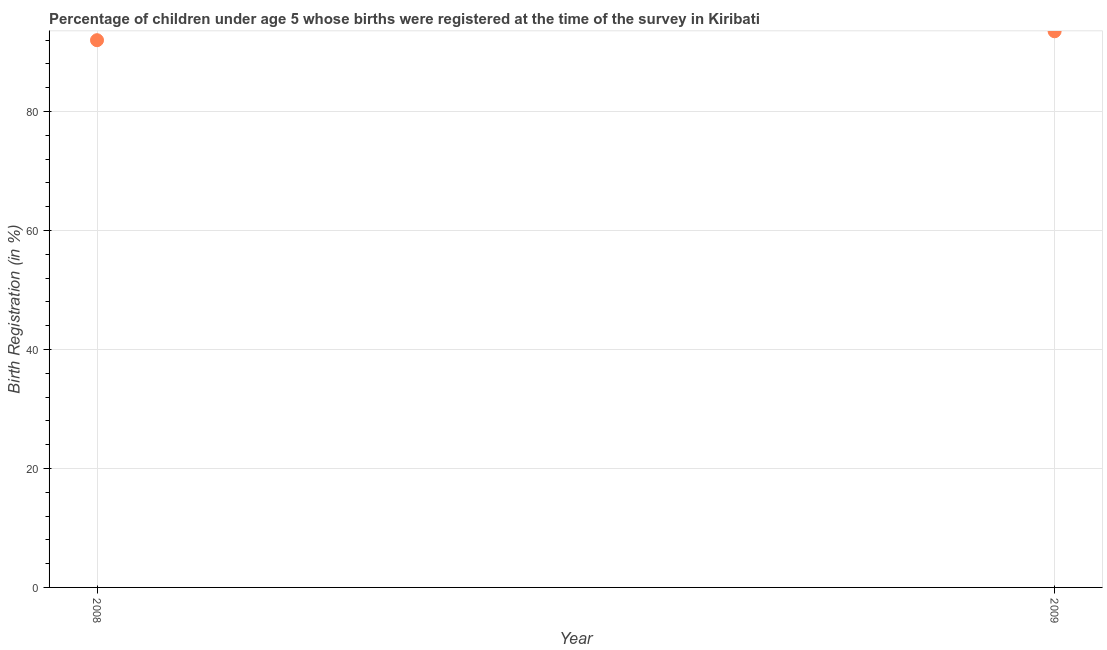What is the birth registration in 2008?
Give a very brief answer. 92. Across all years, what is the maximum birth registration?
Your answer should be compact. 93.5. Across all years, what is the minimum birth registration?
Give a very brief answer. 92. In which year was the birth registration maximum?
Your answer should be very brief. 2009. What is the sum of the birth registration?
Keep it short and to the point. 185.5. What is the difference between the birth registration in 2008 and 2009?
Give a very brief answer. -1.5. What is the average birth registration per year?
Provide a short and direct response. 92.75. What is the median birth registration?
Provide a short and direct response. 92.75. What is the ratio of the birth registration in 2008 to that in 2009?
Your answer should be very brief. 0.98. In how many years, is the birth registration greater than the average birth registration taken over all years?
Your answer should be compact. 1. Does the birth registration monotonically increase over the years?
Your answer should be very brief. Yes. How many dotlines are there?
Provide a short and direct response. 1. What is the title of the graph?
Your answer should be very brief. Percentage of children under age 5 whose births were registered at the time of the survey in Kiribati. What is the label or title of the Y-axis?
Ensure brevity in your answer.  Birth Registration (in %). What is the Birth Registration (in %) in 2008?
Provide a succinct answer. 92. What is the Birth Registration (in %) in 2009?
Give a very brief answer. 93.5. What is the ratio of the Birth Registration (in %) in 2008 to that in 2009?
Ensure brevity in your answer.  0.98. 